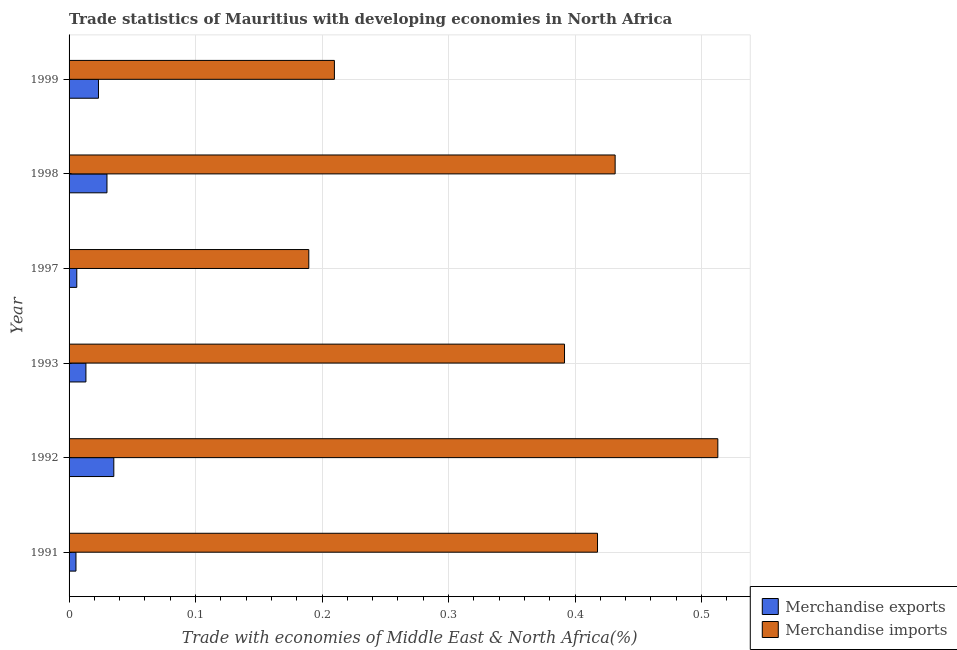How many bars are there on the 3rd tick from the bottom?
Give a very brief answer. 2. What is the merchandise imports in 1993?
Ensure brevity in your answer.  0.39. Across all years, what is the maximum merchandise exports?
Provide a short and direct response. 0.04. Across all years, what is the minimum merchandise exports?
Provide a succinct answer. 0.01. In which year was the merchandise imports minimum?
Offer a very short reply. 1997. What is the total merchandise imports in the graph?
Your answer should be compact. 2.15. What is the difference between the merchandise imports in 1991 and that in 1998?
Offer a terse response. -0.01. What is the difference between the merchandise exports in 1992 and the merchandise imports in 1999?
Keep it short and to the point. -0.17. What is the average merchandise exports per year?
Give a very brief answer. 0.02. In the year 1992, what is the difference between the merchandise imports and merchandise exports?
Your answer should be very brief. 0.48. In how many years, is the merchandise exports greater than 0.30000000000000004 %?
Provide a short and direct response. 0. What is the ratio of the merchandise exports in 1991 to that in 1997?
Make the answer very short. 0.9. Is the merchandise imports in 1992 less than that in 1993?
Make the answer very short. No. What is the difference between the highest and the second highest merchandise imports?
Your answer should be compact. 0.08. Is the sum of the merchandise exports in 1993 and 1998 greater than the maximum merchandise imports across all years?
Your answer should be compact. No. What does the 1st bar from the top in 1997 represents?
Ensure brevity in your answer.  Merchandise imports. How many bars are there?
Your answer should be compact. 12. Does the graph contain any zero values?
Give a very brief answer. No. Does the graph contain grids?
Your answer should be very brief. Yes. Where does the legend appear in the graph?
Give a very brief answer. Bottom right. How many legend labels are there?
Give a very brief answer. 2. What is the title of the graph?
Provide a succinct answer. Trade statistics of Mauritius with developing economies in North Africa. Does "Frequency of shipment arrival" appear as one of the legend labels in the graph?
Make the answer very short. No. What is the label or title of the X-axis?
Your answer should be compact. Trade with economies of Middle East & North Africa(%). What is the Trade with economies of Middle East & North Africa(%) of Merchandise exports in 1991?
Ensure brevity in your answer.  0.01. What is the Trade with economies of Middle East & North Africa(%) of Merchandise imports in 1991?
Ensure brevity in your answer.  0.42. What is the Trade with economies of Middle East & North Africa(%) of Merchandise exports in 1992?
Your answer should be compact. 0.04. What is the Trade with economies of Middle East & North Africa(%) in Merchandise imports in 1992?
Make the answer very short. 0.51. What is the Trade with economies of Middle East & North Africa(%) in Merchandise exports in 1993?
Ensure brevity in your answer.  0.01. What is the Trade with economies of Middle East & North Africa(%) in Merchandise imports in 1993?
Provide a succinct answer. 0.39. What is the Trade with economies of Middle East & North Africa(%) of Merchandise exports in 1997?
Make the answer very short. 0.01. What is the Trade with economies of Middle East & North Africa(%) in Merchandise imports in 1997?
Give a very brief answer. 0.19. What is the Trade with economies of Middle East & North Africa(%) in Merchandise exports in 1998?
Give a very brief answer. 0.03. What is the Trade with economies of Middle East & North Africa(%) in Merchandise imports in 1998?
Your response must be concise. 0.43. What is the Trade with economies of Middle East & North Africa(%) in Merchandise exports in 1999?
Keep it short and to the point. 0.02. What is the Trade with economies of Middle East & North Africa(%) in Merchandise imports in 1999?
Your answer should be compact. 0.21. Across all years, what is the maximum Trade with economies of Middle East & North Africa(%) in Merchandise exports?
Offer a terse response. 0.04. Across all years, what is the maximum Trade with economies of Middle East & North Africa(%) in Merchandise imports?
Give a very brief answer. 0.51. Across all years, what is the minimum Trade with economies of Middle East & North Africa(%) of Merchandise exports?
Provide a succinct answer. 0.01. Across all years, what is the minimum Trade with economies of Middle East & North Africa(%) of Merchandise imports?
Your answer should be very brief. 0.19. What is the total Trade with economies of Middle East & North Africa(%) of Merchandise exports in the graph?
Your answer should be compact. 0.11. What is the total Trade with economies of Middle East & North Africa(%) in Merchandise imports in the graph?
Ensure brevity in your answer.  2.15. What is the difference between the Trade with economies of Middle East & North Africa(%) in Merchandise exports in 1991 and that in 1992?
Your response must be concise. -0.03. What is the difference between the Trade with economies of Middle East & North Africa(%) in Merchandise imports in 1991 and that in 1992?
Ensure brevity in your answer.  -0.1. What is the difference between the Trade with economies of Middle East & North Africa(%) in Merchandise exports in 1991 and that in 1993?
Your answer should be compact. -0.01. What is the difference between the Trade with economies of Middle East & North Africa(%) in Merchandise imports in 1991 and that in 1993?
Ensure brevity in your answer.  0.03. What is the difference between the Trade with economies of Middle East & North Africa(%) in Merchandise exports in 1991 and that in 1997?
Provide a succinct answer. -0. What is the difference between the Trade with economies of Middle East & North Africa(%) in Merchandise imports in 1991 and that in 1997?
Make the answer very short. 0.23. What is the difference between the Trade with economies of Middle East & North Africa(%) in Merchandise exports in 1991 and that in 1998?
Keep it short and to the point. -0.02. What is the difference between the Trade with economies of Middle East & North Africa(%) of Merchandise imports in 1991 and that in 1998?
Make the answer very short. -0.01. What is the difference between the Trade with economies of Middle East & North Africa(%) in Merchandise exports in 1991 and that in 1999?
Make the answer very short. -0.02. What is the difference between the Trade with economies of Middle East & North Africa(%) in Merchandise imports in 1991 and that in 1999?
Your answer should be very brief. 0.21. What is the difference between the Trade with economies of Middle East & North Africa(%) in Merchandise exports in 1992 and that in 1993?
Offer a very short reply. 0.02. What is the difference between the Trade with economies of Middle East & North Africa(%) in Merchandise imports in 1992 and that in 1993?
Give a very brief answer. 0.12. What is the difference between the Trade with economies of Middle East & North Africa(%) in Merchandise exports in 1992 and that in 1997?
Provide a short and direct response. 0.03. What is the difference between the Trade with economies of Middle East & North Africa(%) in Merchandise imports in 1992 and that in 1997?
Make the answer very short. 0.32. What is the difference between the Trade with economies of Middle East & North Africa(%) in Merchandise exports in 1992 and that in 1998?
Your answer should be very brief. 0.01. What is the difference between the Trade with economies of Middle East & North Africa(%) in Merchandise imports in 1992 and that in 1998?
Your response must be concise. 0.08. What is the difference between the Trade with economies of Middle East & North Africa(%) of Merchandise exports in 1992 and that in 1999?
Make the answer very short. 0.01. What is the difference between the Trade with economies of Middle East & North Africa(%) in Merchandise imports in 1992 and that in 1999?
Give a very brief answer. 0.3. What is the difference between the Trade with economies of Middle East & North Africa(%) of Merchandise exports in 1993 and that in 1997?
Give a very brief answer. 0.01. What is the difference between the Trade with economies of Middle East & North Africa(%) in Merchandise imports in 1993 and that in 1997?
Make the answer very short. 0.2. What is the difference between the Trade with economies of Middle East & North Africa(%) in Merchandise exports in 1993 and that in 1998?
Offer a very short reply. -0.02. What is the difference between the Trade with economies of Middle East & North Africa(%) of Merchandise imports in 1993 and that in 1998?
Offer a terse response. -0.04. What is the difference between the Trade with economies of Middle East & North Africa(%) in Merchandise exports in 1993 and that in 1999?
Offer a very short reply. -0.01. What is the difference between the Trade with economies of Middle East & North Africa(%) of Merchandise imports in 1993 and that in 1999?
Give a very brief answer. 0.18. What is the difference between the Trade with economies of Middle East & North Africa(%) of Merchandise exports in 1997 and that in 1998?
Ensure brevity in your answer.  -0.02. What is the difference between the Trade with economies of Middle East & North Africa(%) of Merchandise imports in 1997 and that in 1998?
Make the answer very short. -0.24. What is the difference between the Trade with economies of Middle East & North Africa(%) of Merchandise exports in 1997 and that in 1999?
Provide a short and direct response. -0.02. What is the difference between the Trade with economies of Middle East & North Africa(%) of Merchandise imports in 1997 and that in 1999?
Offer a very short reply. -0.02. What is the difference between the Trade with economies of Middle East & North Africa(%) of Merchandise exports in 1998 and that in 1999?
Offer a terse response. 0.01. What is the difference between the Trade with economies of Middle East & North Africa(%) in Merchandise imports in 1998 and that in 1999?
Your response must be concise. 0.22. What is the difference between the Trade with economies of Middle East & North Africa(%) of Merchandise exports in 1991 and the Trade with economies of Middle East & North Africa(%) of Merchandise imports in 1992?
Offer a terse response. -0.51. What is the difference between the Trade with economies of Middle East & North Africa(%) of Merchandise exports in 1991 and the Trade with economies of Middle East & North Africa(%) of Merchandise imports in 1993?
Give a very brief answer. -0.39. What is the difference between the Trade with economies of Middle East & North Africa(%) of Merchandise exports in 1991 and the Trade with economies of Middle East & North Africa(%) of Merchandise imports in 1997?
Ensure brevity in your answer.  -0.18. What is the difference between the Trade with economies of Middle East & North Africa(%) in Merchandise exports in 1991 and the Trade with economies of Middle East & North Africa(%) in Merchandise imports in 1998?
Your answer should be compact. -0.43. What is the difference between the Trade with economies of Middle East & North Africa(%) in Merchandise exports in 1991 and the Trade with economies of Middle East & North Africa(%) in Merchandise imports in 1999?
Offer a very short reply. -0.2. What is the difference between the Trade with economies of Middle East & North Africa(%) in Merchandise exports in 1992 and the Trade with economies of Middle East & North Africa(%) in Merchandise imports in 1993?
Make the answer very short. -0.36. What is the difference between the Trade with economies of Middle East & North Africa(%) in Merchandise exports in 1992 and the Trade with economies of Middle East & North Africa(%) in Merchandise imports in 1997?
Your answer should be compact. -0.15. What is the difference between the Trade with economies of Middle East & North Africa(%) in Merchandise exports in 1992 and the Trade with economies of Middle East & North Africa(%) in Merchandise imports in 1998?
Provide a short and direct response. -0.4. What is the difference between the Trade with economies of Middle East & North Africa(%) of Merchandise exports in 1992 and the Trade with economies of Middle East & North Africa(%) of Merchandise imports in 1999?
Provide a short and direct response. -0.17. What is the difference between the Trade with economies of Middle East & North Africa(%) in Merchandise exports in 1993 and the Trade with economies of Middle East & North Africa(%) in Merchandise imports in 1997?
Give a very brief answer. -0.18. What is the difference between the Trade with economies of Middle East & North Africa(%) of Merchandise exports in 1993 and the Trade with economies of Middle East & North Africa(%) of Merchandise imports in 1998?
Give a very brief answer. -0.42. What is the difference between the Trade with economies of Middle East & North Africa(%) in Merchandise exports in 1993 and the Trade with economies of Middle East & North Africa(%) in Merchandise imports in 1999?
Your answer should be very brief. -0.2. What is the difference between the Trade with economies of Middle East & North Africa(%) in Merchandise exports in 1997 and the Trade with economies of Middle East & North Africa(%) in Merchandise imports in 1998?
Offer a terse response. -0.43. What is the difference between the Trade with economies of Middle East & North Africa(%) in Merchandise exports in 1997 and the Trade with economies of Middle East & North Africa(%) in Merchandise imports in 1999?
Give a very brief answer. -0.2. What is the difference between the Trade with economies of Middle East & North Africa(%) in Merchandise exports in 1998 and the Trade with economies of Middle East & North Africa(%) in Merchandise imports in 1999?
Your answer should be very brief. -0.18. What is the average Trade with economies of Middle East & North Africa(%) in Merchandise exports per year?
Your response must be concise. 0.02. What is the average Trade with economies of Middle East & North Africa(%) in Merchandise imports per year?
Offer a terse response. 0.36. In the year 1991, what is the difference between the Trade with economies of Middle East & North Africa(%) in Merchandise exports and Trade with economies of Middle East & North Africa(%) in Merchandise imports?
Offer a very short reply. -0.41. In the year 1992, what is the difference between the Trade with economies of Middle East & North Africa(%) in Merchandise exports and Trade with economies of Middle East & North Africa(%) in Merchandise imports?
Keep it short and to the point. -0.48. In the year 1993, what is the difference between the Trade with economies of Middle East & North Africa(%) in Merchandise exports and Trade with economies of Middle East & North Africa(%) in Merchandise imports?
Ensure brevity in your answer.  -0.38. In the year 1997, what is the difference between the Trade with economies of Middle East & North Africa(%) of Merchandise exports and Trade with economies of Middle East & North Africa(%) of Merchandise imports?
Offer a very short reply. -0.18. In the year 1998, what is the difference between the Trade with economies of Middle East & North Africa(%) of Merchandise exports and Trade with economies of Middle East & North Africa(%) of Merchandise imports?
Make the answer very short. -0.4. In the year 1999, what is the difference between the Trade with economies of Middle East & North Africa(%) of Merchandise exports and Trade with economies of Middle East & North Africa(%) of Merchandise imports?
Keep it short and to the point. -0.19. What is the ratio of the Trade with economies of Middle East & North Africa(%) of Merchandise exports in 1991 to that in 1992?
Offer a very short reply. 0.15. What is the ratio of the Trade with economies of Middle East & North Africa(%) in Merchandise imports in 1991 to that in 1992?
Provide a succinct answer. 0.81. What is the ratio of the Trade with economies of Middle East & North Africa(%) in Merchandise exports in 1991 to that in 1993?
Keep it short and to the point. 0.41. What is the ratio of the Trade with economies of Middle East & North Africa(%) of Merchandise imports in 1991 to that in 1993?
Your response must be concise. 1.07. What is the ratio of the Trade with economies of Middle East & North Africa(%) in Merchandise exports in 1991 to that in 1997?
Your answer should be very brief. 0.89. What is the ratio of the Trade with economies of Middle East & North Africa(%) in Merchandise imports in 1991 to that in 1997?
Your answer should be very brief. 2.2. What is the ratio of the Trade with economies of Middle East & North Africa(%) of Merchandise exports in 1991 to that in 1998?
Give a very brief answer. 0.18. What is the ratio of the Trade with economies of Middle East & North Africa(%) in Merchandise exports in 1991 to that in 1999?
Your response must be concise. 0.23. What is the ratio of the Trade with economies of Middle East & North Africa(%) of Merchandise imports in 1991 to that in 1999?
Give a very brief answer. 1.99. What is the ratio of the Trade with economies of Middle East & North Africa(%) in Merchandise exports in 1992 to that in 1993?
Your answer should be very brief. 2.65. What is the ratio of the Trade with economies of Middle East & North Africa(%) in Merchandise imports in 1992 to that in 1993?
Your response must be concise. 1.31. What is the ratio of the Trade with economies of Middle East & North Africa(%) of Merchandise exports in 1992 to that in 1997?
Provide a succinct answer. 5.8. What is the ratio of the Trade with economies of Middle East & North Africa(%) of Merchandise imports in 1992 to that in 1997?
Make the answer very short. 2.71. What is the ratio of the Trade with economies of Middle East & North Africa(%) of Merchandise exports in 1992 to that in 1998?
Offer a terse response. 1.18. What is the ratio of the Trade with economies of Middle East & North Africa(%) of Merchandise imports in 1992 to that in 1998?
Your response must be concise. 1.19. What is the ratio of the Trade with economies of Middle East & North Africa(%) in Merchandise exports in 1992 to that in 1999?
Give a very brief answer. 1.52. What is the ratio of the Trade with economies of Middle East & North Africa(%) of Merchandise imports in 1992 to that in 1999?
Provide a short and direct response. 2.45. What is the ratio of the Trade with economies of Middle East & North Africa(%) of Merchandise exports in 1993 to that in 1997?
Your response must be concise. 2.19. What is the ratio of the Trade with economies of Middle East & North Africa(%) in Merchandise imports in 1993 to that in 1997?
Your answer should be very brief. 2.07. What is the ratio of the Trade with economies of Middle East & North Africa(%) of Merchandise exports in 1993 to that in 1998?
Keep it short and to the point. 0.44. What is the ratio of the Trade with economies of Middle East & North Africa(%) of Merchandise imports in 1993 to that in 1998?
Provide a succinct answer. 0.91. What is the ratio of the Trade with economies of Middle East & North Africa(%) of Merchandise exports in 1993 to that in 1999?
Your answer should be compact. 0.57. What is the ratio of the Trade with economies of Middle East & North Africa(%) in Merchandise imports in 1993 to that in 1999?
Provide a succinct answer. 1.87. What is the ratio of the Trade with economies of Middle East & North Africa(%) of Merchandise exports in 1997 to that in 1998?
Provide a short and direct response. 0.2. What is the ratio of the Trade with economies of Middle East & North Africa(%) of Merchandise imports in 1997 to that in 1998?
Keep it short and to the point. 0.44. What is the ratio of the Trade with economies of Middle East & North Africa(%) of Merchandise exports in 1997 to that in 1999?
Provide a succinct answer. 0.26. What is the ratio of the Trade with economies of Middle East & North Africa(%) in Merchandise imports in 1997 to that in 1999?
Keep it short and to the point. 0.9. What is the ratio of the Trade with economies of Middle East & North Africa(%) in Merchandise exports in 1998 to that in 1999?
Offer a terse response. 1.29. What is the ratio of the Trade with economies of Middle East & North Africa(%) in Merchandise imports in 1998 to that in 1999?
Make the answer very short. 2.06. What is the difference between the highest and the second highest Trade with economies of Middle East & North Africa(%) of Merchandise exports?
Provide a succinct answer. 0.01. What is the difference between the highest and the second highest Trade with economies of Middle East & North Africa(%) in Merchandise imports?
Provide a succinct answer. 0.08. What is the difference between the highest and the lowest Trade with economies of Middle East & North Africa(%) in Merchandise exports?
Give a very brief answer. 0.03. What is the difference between the highest and the lowest Trade with economies of Middle East & North Africa(%) in Merchandise imports?
Keep it short and to the point. 0.32. 